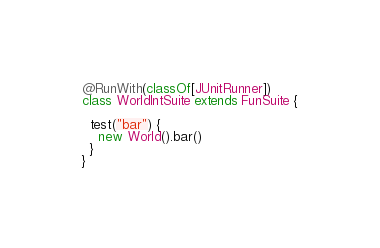<code> <loc_0><loc_0><loc_500><loc_500><_Scala_>
@RunWith(classOf[JUnitRunner])
class WorldIntSuite extends FunSuite {

  test("bar") {
    new World().bar()
  }
}
</code> 